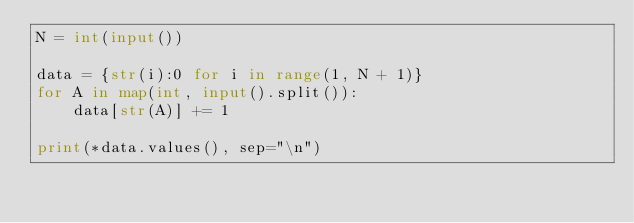<code> <loc_0><loc_0><loc_500><loc_500><_Python_>N = int(input())

data = {str(i):0 for i in range(1, N + 1)}
for A in map(int, input().split()):
    data[str(A)] += 1

print(*data.values(), sep="\n")</code> 